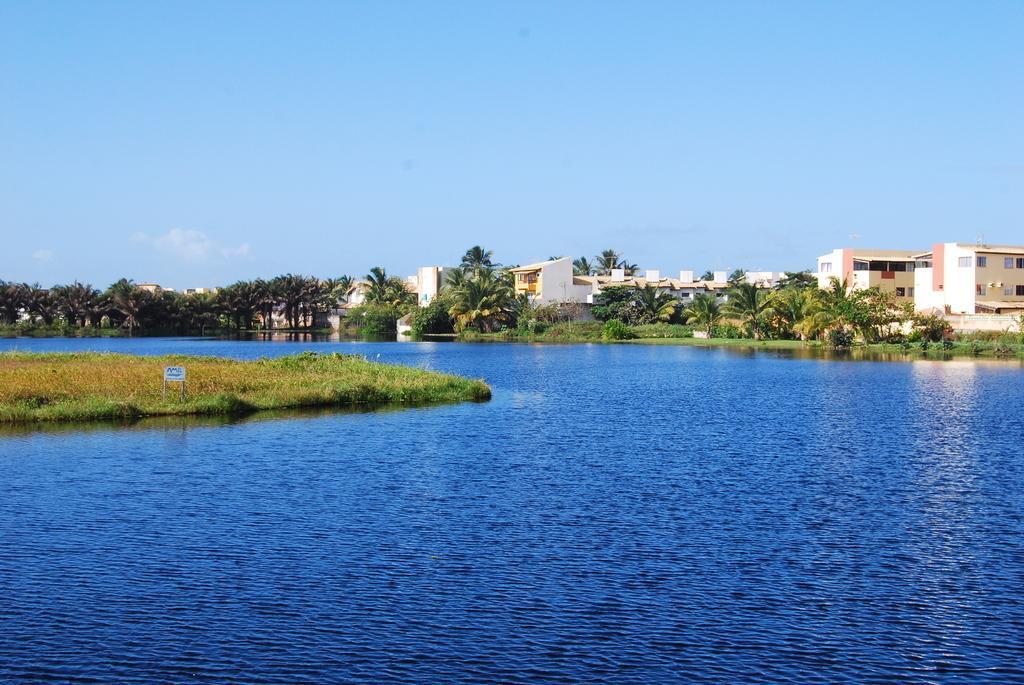Could you give a brief overview of what you see in this image? In this image we can see many trees and also some buildings. We can also see the grass, a sign board and also the water. At the top there is sky. 